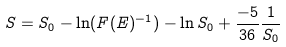Convert formula to latex. <formula><loc_0><loc_0><loc_500><loc_500>S = S _ { 0 } - \ln ( F ( E ) ^ { - 1 } ) - \ln S _ { 0 } + \frac { - 5 } { 3 6 } \frac { 1 } { S _ { 0 } }</formula> 